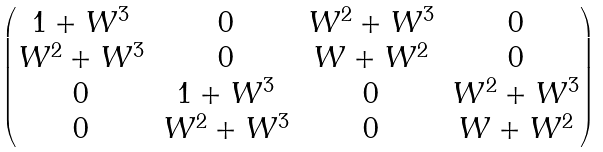<formula> <loc_0><loc_0><loc_500><loc_500>\begin{pmatrix} 1 + W ^ { 3 } & 0 & W ^ { 2 } + W ^ { 3 } & 0 \\ W ^ { 2 } + W ^ { 3 } & 0 & W + W ^ { 2 } & 0 \\ 0 & 1 + W ^ { 3 } & 0 & W ^ { 2 } + W ^ { 3 } \\ 0 & W ^ { 2 } + W ^ { 3 } & 0 & W + W ^ { 2 } \end{pmatrix}</formula> 